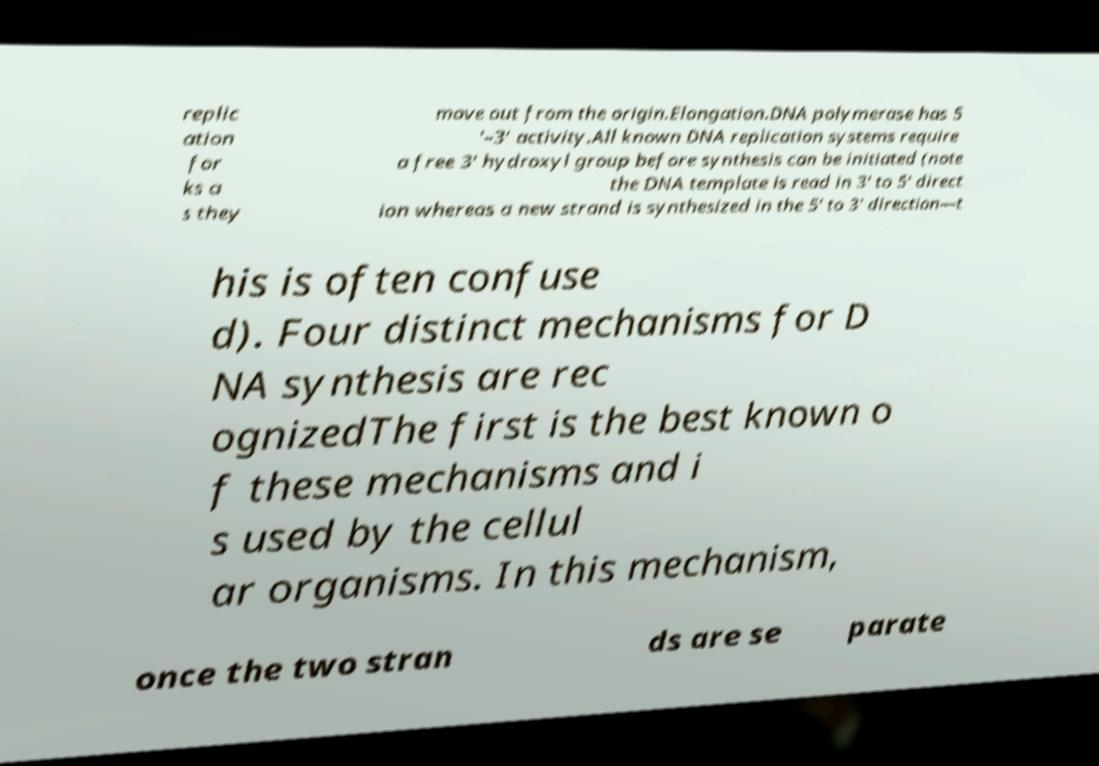Please identify and transcribe the text found in this image. replic ation for ks a s they move out from the origin.Elongation.DNA polymerase has 5 ′–3′ activity.All known DNA replication systems require a free 3′ hydroxyl group before synthesis can be initiated (note the DNA template is read in 3′ to 5′ direct ion whereas a new strand is synthesized in the 5′ to 3′ direction—t his is often confuse d). Four distinct mechanisms for D NA synthesis are rec ognizedThe first is the best known o f these mechanisms and i s used by the cellul ar organisms. In this mechanism, once the two stran ds are se parate 